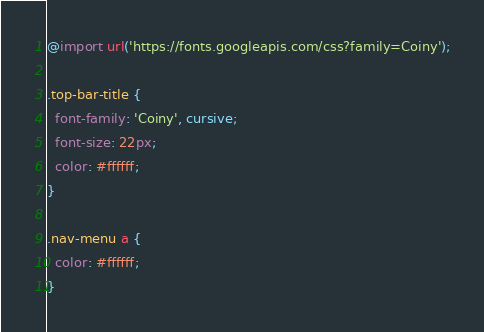Convert code to text. <code><loc_0><loc_0><loc_500><loc_500><_CSS_>@import url('https://fonts.googleapis.com/css?family=Coiny');

.top-bar-title {
  font-family: 'Coiny', cursive;
  font-size: 22px;
  color: #ffffff;
}

.nav-menu a {
  color: #ffffff;
}
</code> 